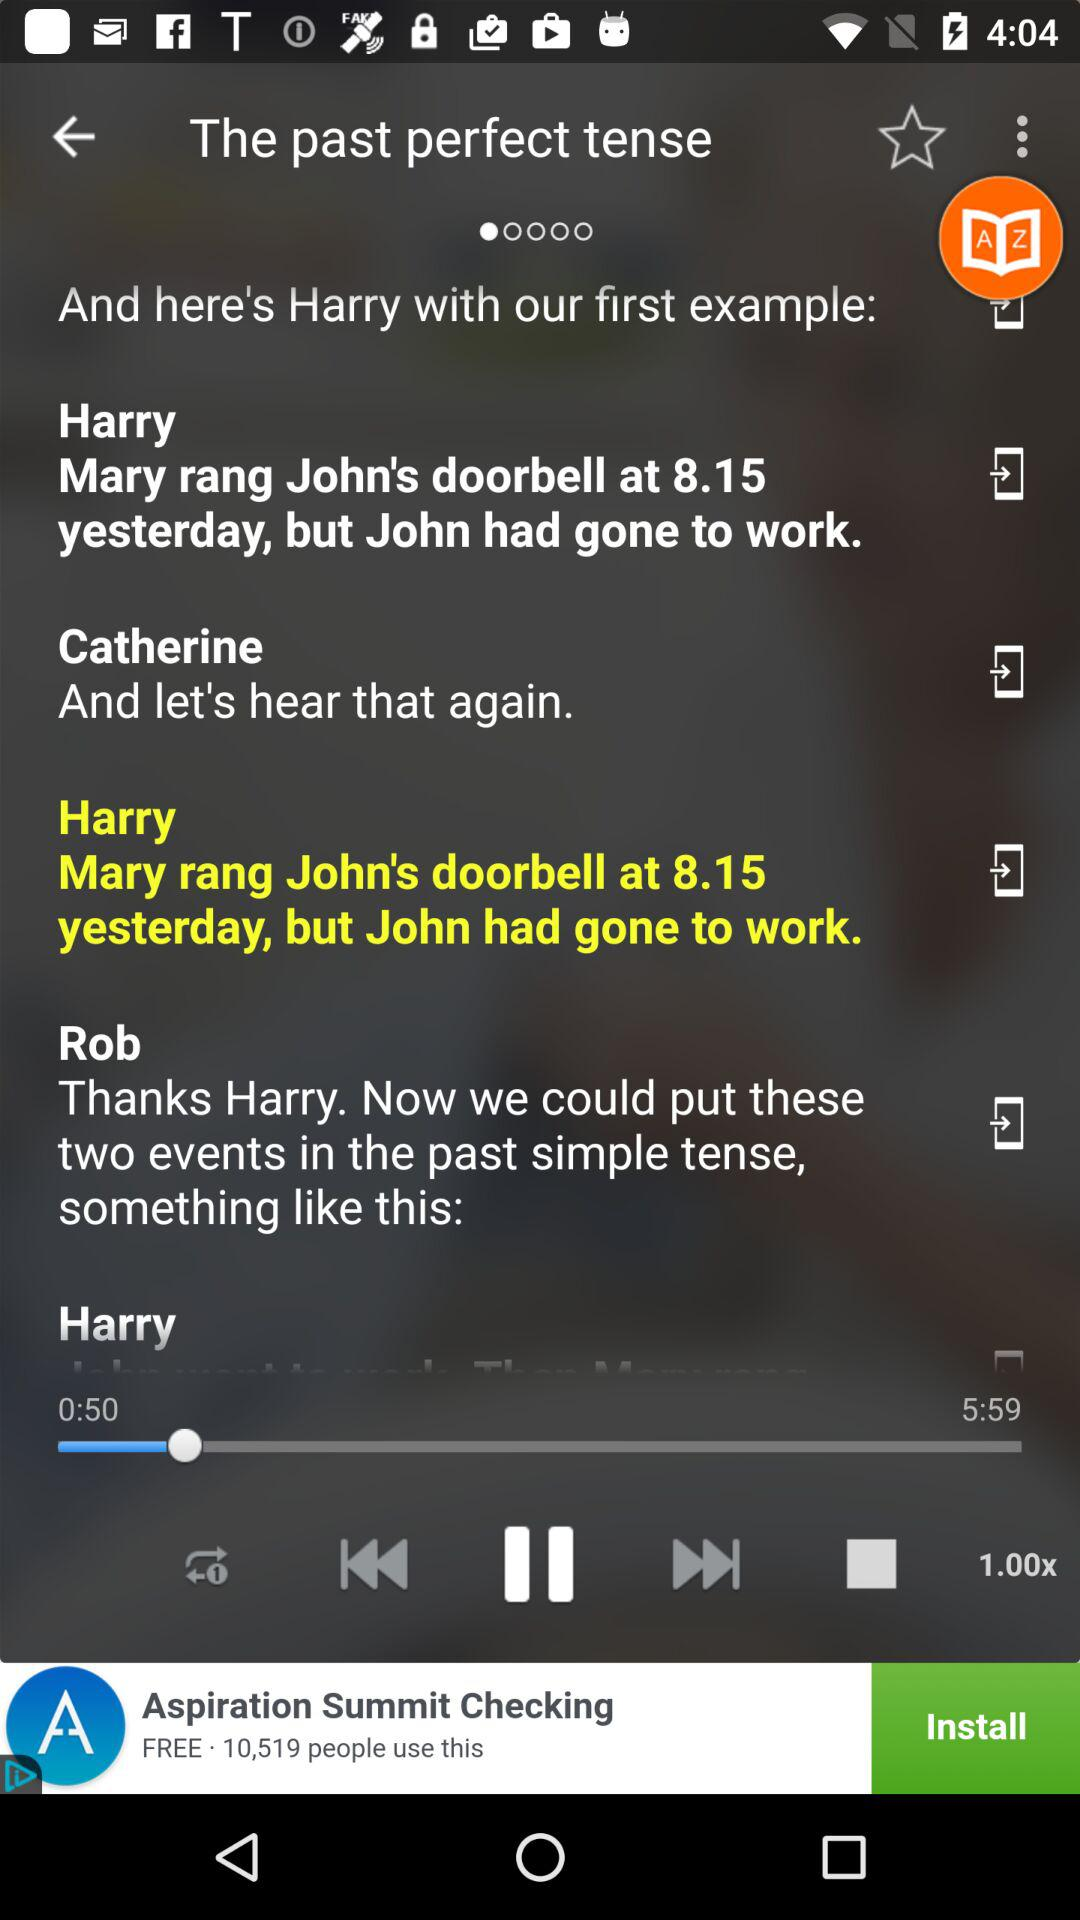How many people are on the screen?
Answer the question using a single word or phrase. 3 